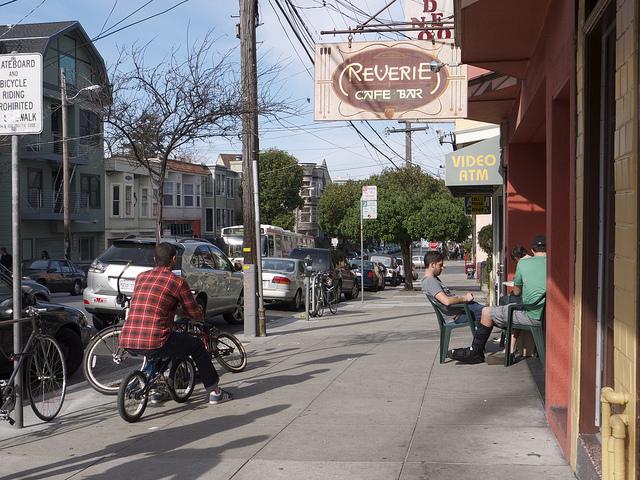Is the man riding a bike that is meant for children or adults?
Write a very short answer. Children. Is bicycle riding on the sidewalk allowed?
Concise answer only. No. Is this a rural area?
Give a very brief answer. No. 